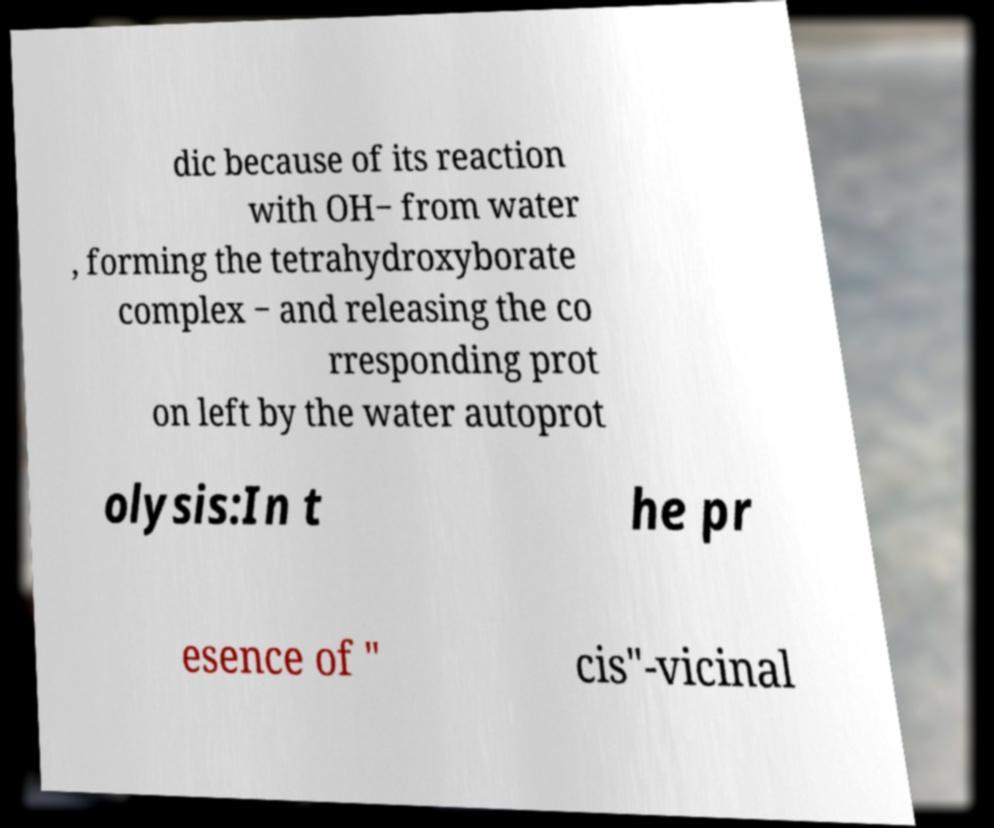I need the written content from this picture converted into text. Can you do that? dic because of its reaction with OH− from water , forming the tetrahydroxyborate complex − and releasing the co rresponding prot on left by the water autoprot olysis:In t he pr esence of " cis"-vicinal 